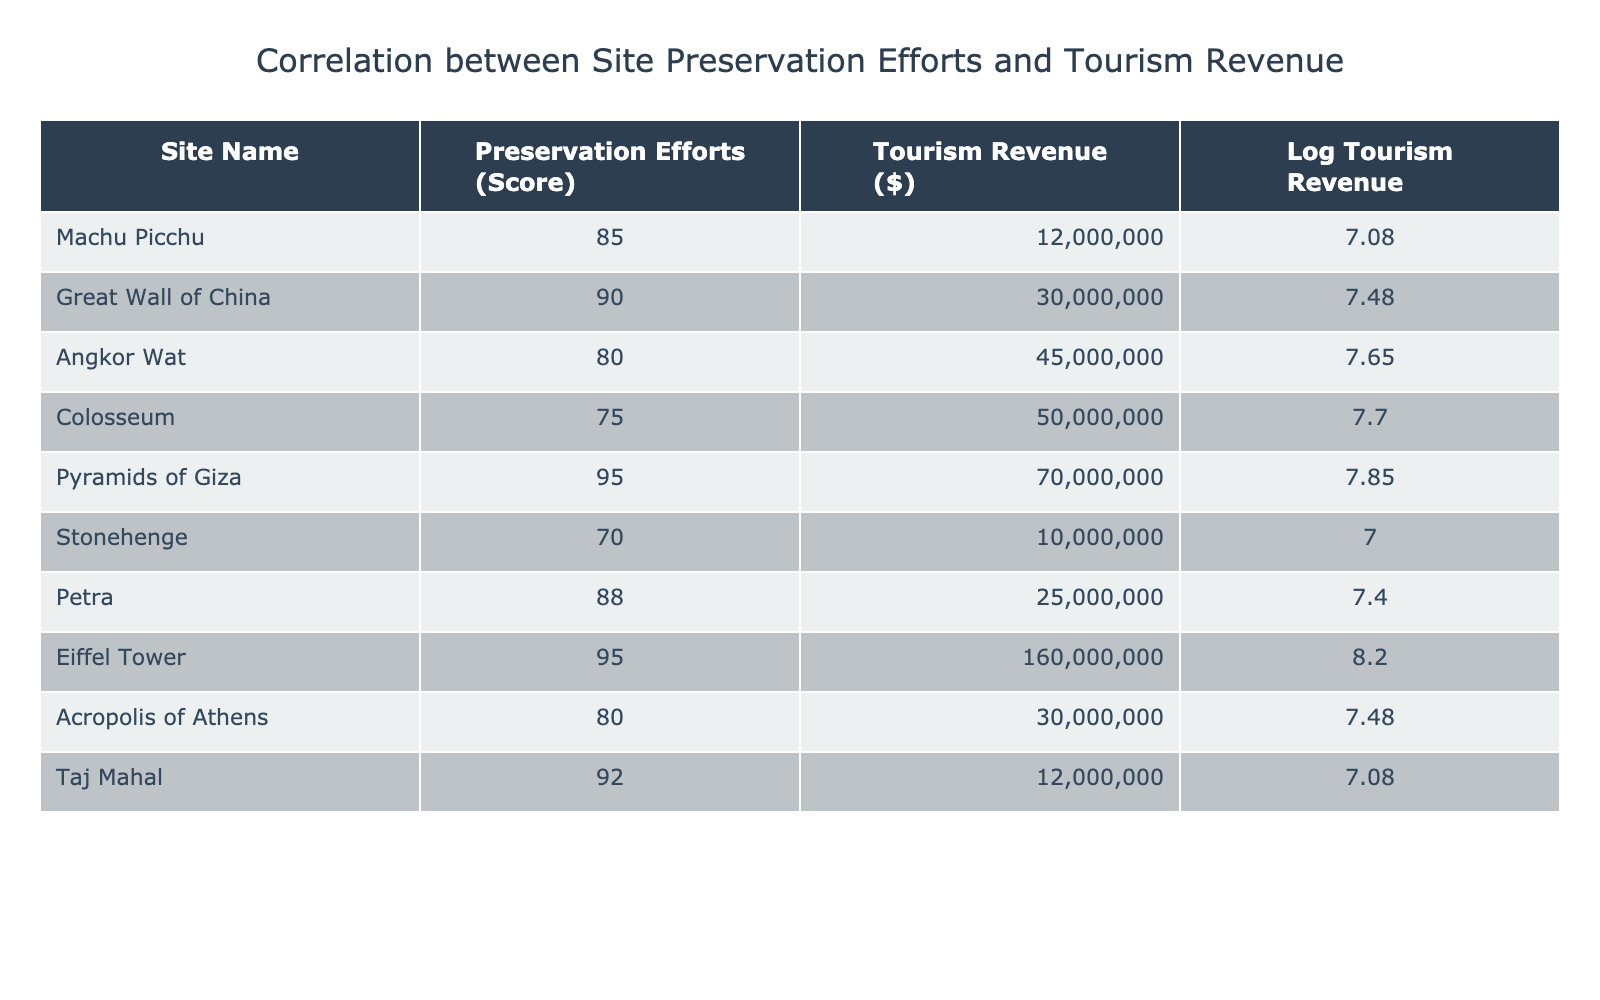What is the highest tourism revenue recorded in the table? The table lists the tourism revenue for each site. Scanning through the values, the highest revenue is noted for the Eiffel Tower at $160,000,000.
Answer: $160,000,000 Which site has a preservation score of 95? From the table, both the Pyramids of Giza and the Eiffel Tower have a preservation score of 95.
Answer: Pyramids of Giza and Eiffel Tower What is the average preservation score of all the sites listed? To find the average, add together all the preservation scores: 85 + 90 + 80 + 75 + 95 + 70 + 88 + 95 + 80 + 92 =  915. There are 10 sites, so divide 915 by 10, which results in 91.5.
Answer: 91.5 Is it true that Angkor Wat generated more tourism revenue than Machu Picchu? Checking the tourism revenue figures, Angkor Wat has a revenue of $45,000,000, while Machu Picchu has $12,000,000. Since 45 million is greater than 12 million, the answer is yes.
Answer: Yes What is the logarithmic value of the tourism revenue for the Colosseum? The tourism revenue for the Colosseum is $50,000,000. Applying the logarithmic transformation, we calculate log10(50,000,000) which is approximately 7.69 when rounded to two decimal places.
Answer: 7.69 Which site has the lowest preservation efforts score and what is its tourism revenue? The site with the lowest preservation score is Stonehenge at a score of 70. According to the table, its tourism revenue is $10,000,000.
Answer: Stonehenge, $10,000,000 What is the difference in tourism revenue between the site with the highest score and the lowest score? The highest preservation score is 95 (Pyramids of Giza and Eiffel Tower) and the lowest is 70 (Stonehenge). The tourism revenues are $70,000,000 for the Pyramids of Giza and $10,000,000 for Stonehenge. The difference is calculated as $70,000,000 - $10,000,000 = $60,000,000.
Answer: $60,000,000 How many tourist sites have a revenue greater than $30 million? From the table, the sites exceeding $30 million in revenue are Great Wall of China, Angkor Wat, Colosseum, Pyramids of Giza, Eiffel Tower, and Petra, totaling 6 sites.
Answer: 6 